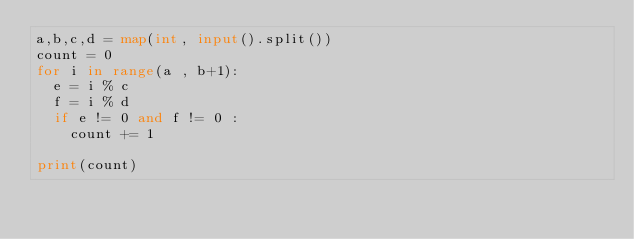Convert code to text. <code><loc_0><loc_0><loc_500><loc_500><_Python_>a,b,c,d = map(int, input().split())
count = 0
for i in range(a , b+1):
  e = i % c
  f = i % d
  if e != 0 and f != 0 :
    count += 1
    
print(count)</code> 